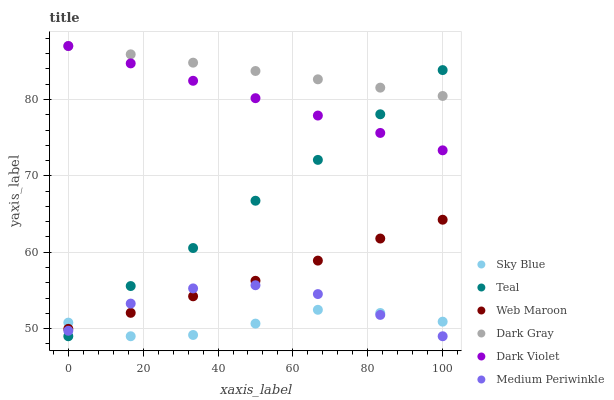Does Sky Blue have the minimum area under the curve?
Answer yes or no. Yes. Does Dark Gray have the maximum area under the curve?
Answer yes or no. Yes. Does Web Maroon have the minimum area under the curve?
Answer yes or no. No. Does Web Maroon have the maximum area under the curve?
Answer yes or no. No. Is Dark Violet the smoothest?
Answer yes or no. Yes. Is Sky Blue the roughest?
Answer yes or no. Yes. Is Web Maroon the smoothest?
Answer yes or no. No. Is Web Maroon the roughest?
Answer yes or no. No. Does Medium Periwinkle have the lowest value?
Answer yes or no. Yes. Does Web Maroon have the lowest value?
Answer yes or no. No. Does Dark Gray have the highest value?
Answer yes or no. Yes. Does Web Maroon have the highest value?
Answer yes or no. No. Is Sky Blue less than Dark Gray?
Answer yes or no. Yes. Is Dark Gray greater than Web Maroon?
Answer yes or no. Yes. Does Sky Blue intersect Web Maroon?
Answer yes or no. Yes. Is Sky Blue less than Web Maroon?
Answer yes or no. No. Is Sky Blue greater than Web Maroon?
Answer yes or no. No. Does Sky Blue intersect Dark Gray?
Answer yes or no. No. 